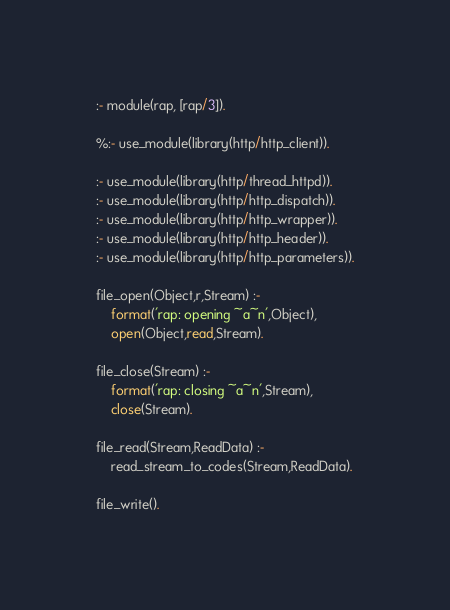<code> <loc_0><loc_0><loc_500><loc_500><_Perl_>:- module(rap, [rap/3]).

%:- use_module(library(http/http_client)).

:- use_module(library(http/thread_httpd)).
:- use_module(library(http/http_dispatch)).
:- use_module(library(http/http_wrapper)).
:- use_module(library(http/http_header)).
:- use_module(library(http/http_parameters)).

file_open(Object,r,Stream) :-
	format('rap: opening ~a~n',Object),
	open(Object,read,Stream).

file_close(Stream) :-
	format('rap: closing ~a~n',Stream),
	close(Stream).

file_read(Stream,ReadData) :-
	read_stream_to_codes(Stream,ReadData).

file_write().
</code> 